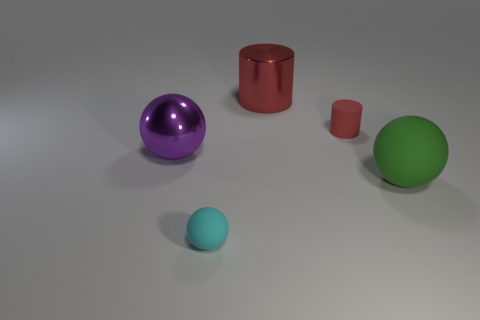There is a tiny rubber cylinder; is its color the same as the big metallic thing that is to the right of the purple sphere?
Provide a succinct answer. Yes. Are there more small gray blocks than red rubber cylinders?
Your answer should be very brief. No. The metallic cylinder has what color?
Offer a terse response. Red. There is a small object behind the cyan sphere; is its color the same as the large cylinder?
Provide a succinct answer. Yes. What material is the small object that is the same color as the big cylinder?
Your response must be concise. Rubber. What number of other small cylinders are the same color as the metallic cylinder?
Keep it short and to the point. 1. There is a thing behind the small red rubber cylinder; does it have the same shape as the red matte object?
Offer a terse response. Yes. Are there fewer big purple objects that are behind the large cylinder than big balls in front of the metallic sphere?
Offer a terse response. Yes. There is a small thing on the right side of the large red thing; what is it made of?
Provide a short and direct response. Rubber. There is another matte cylinder that is the same color as the large cylinder; what is its size?
Provide a short and direct response. Small. 